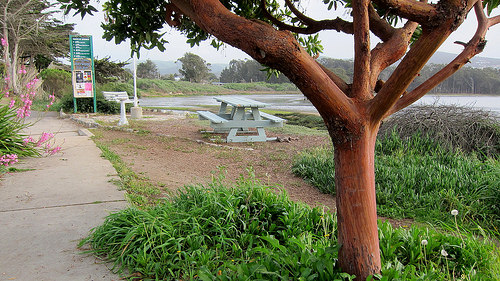<image>
Is the tree in front of the bench? Yes. The tree is positioned in front of the bench, appearing closer to the camera viewpoint. 